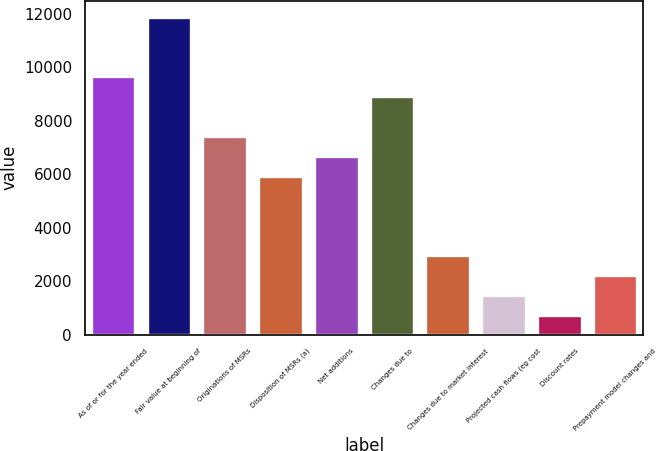<chart> <loc_0><loc_0><loc_500><loc_500><bar_chart><fcel>As of or for the year ended<fcel>Fair value at beginning of<fcel>Originations of MSRs<fcel>Disposition of MSRs (a)<fcel>Net additions<fcel>Changes due to<fcel>Changes due to market interest<fcel>Projected cash flows (eg cost<fcel>Discount rates<fcel>Prepayment model changes and<nl><fcel>9664.85<fcel>11893.7<fcel>7436<fcel>5950.1<fcel>6693.05<fcel>8921.9<fcel>2978.3<fcel>1492.4<fcel>749.45<fcel>2235.35<nl></chart> 